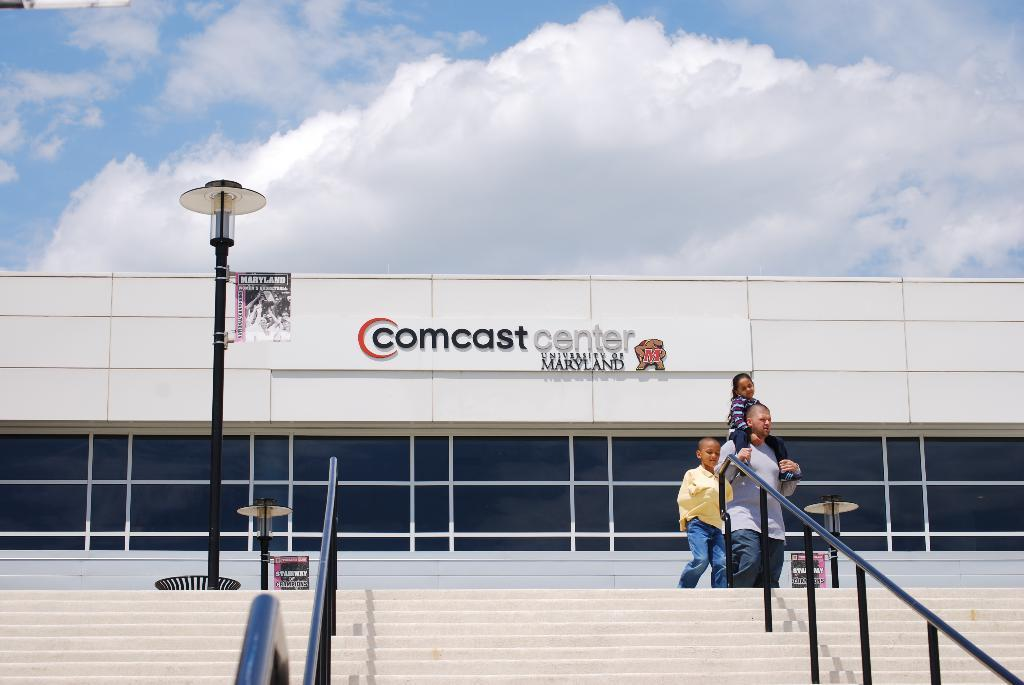How many people are in the image? There are persons standing in the image. What is the surface beneath the people's feet? There is a floor in the image. What architectural feature is present in the image? There is a staircase in the image. What safety feature is present along the staircase? There are railings in the image. What type of urban infrastructure is visible in the image? There are street poles and street lights in the image. What type of structure is present in the image? There is a building in the image. What signage is present in the image? There is a name board in the image. What is visible in the sky in the image? The sky is visible in the image, and there are clouds in the sky. What type of credit card is being used by the person on the staircase? There is no credit card visible in the image, and no person is using a credit card. What is the size of the stick that the street light is holding? There is no stick present in the image, and street lights do not hold sticks. 